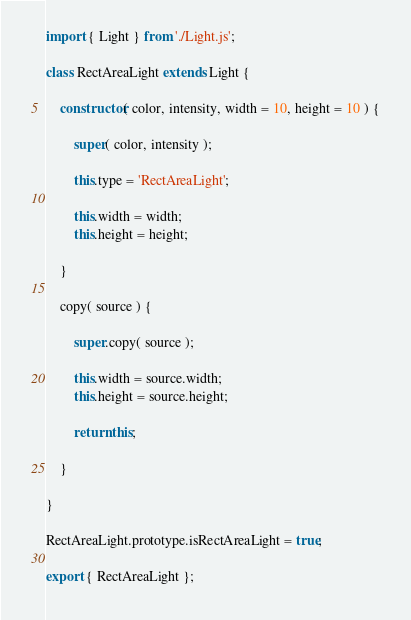Convert code to text. <code><loc_0><loc_0><loc_500><loc_500><_JavaScript_>import { Light } from './Light.js';

class RectAreaLight extends Light {

	constructor( color, intensity, width = 10, height = 10 ) {

		super( color, intensity );

		this.type = 'RectAreaLight';

		this.width = width;
		this.height = height;

	}

	copy( source ) {

		super.copy( source );

		this.width = source.width;
		this.height = source.height;

		return this;

	}

}

RectAreaLight.prototype.isRectAreaLight = true;

export { RectAreaLight };
</code> 